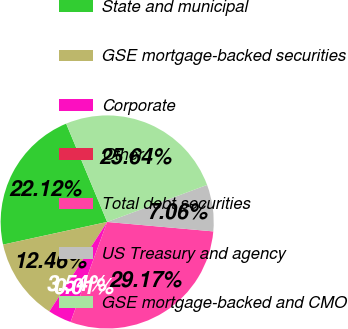Convert chart. <chart><loc_0><loc_0><loc_500><loc_500><pie_chart><fcel>State and municipal<fcel>GSE mortgage-backed securities<fcel>Corporate<fcel>Other<fcel>Total debt securities<fcel>US Treasury and agency<fcel>GSE mortgage-backed and CMO<nl><fcel>22.12%<fcel>12.46%<fcel>3.54%<fcel>0.01%<fcel>29.17%<fcel>7.06%<fcel>25.64%<nl></chart> 